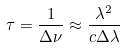Convert formula to latex. <formula><loc_0><loc_0><loc_500><loc_500>\tau = \frac { 1 } { \Delta \nu } \approx \frac { \lambda ^ { 2 } } { c \Delta \lambda }</formula> 